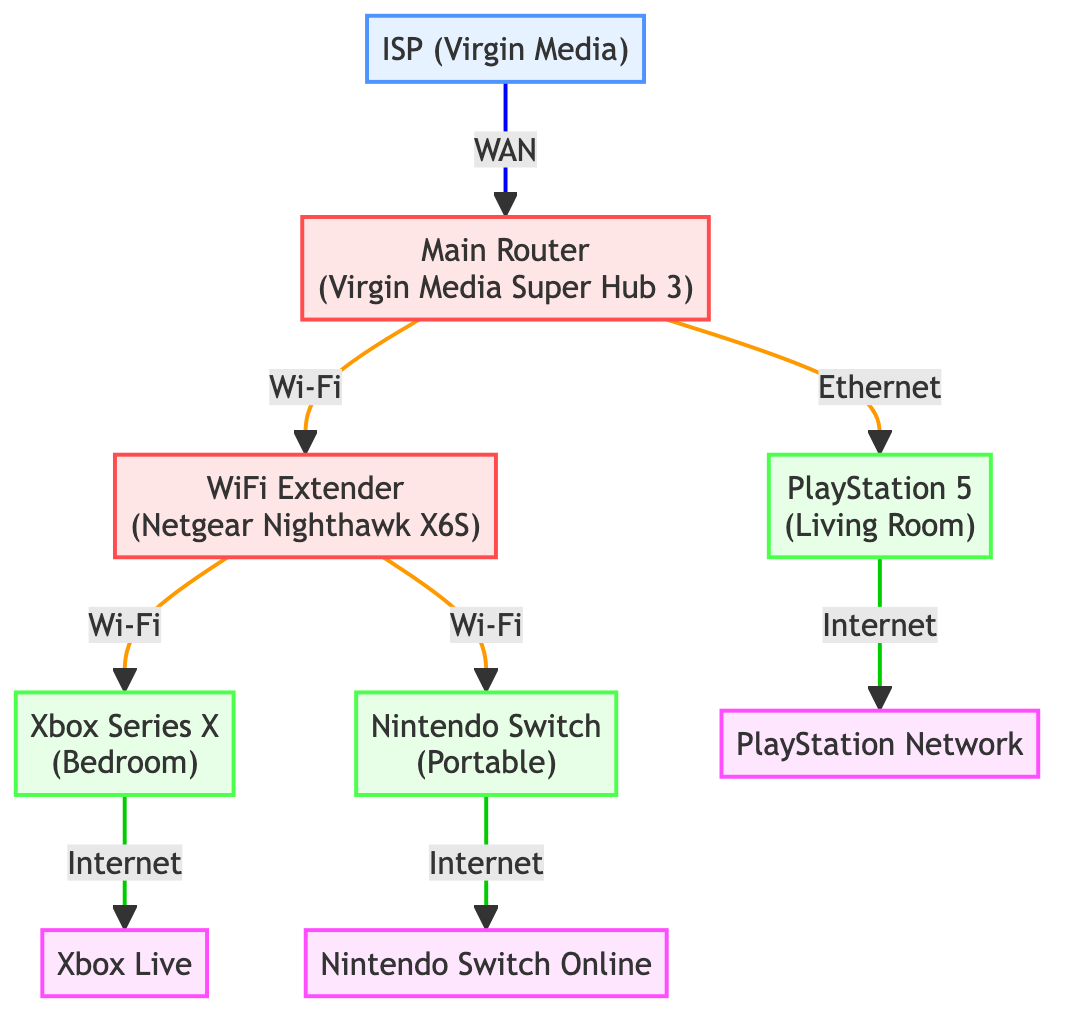What is the primary Internet Service Provider (ISP) represented in the diagram? The diagram specifically notes that the ISP is Virgin Media, which is indicated at the top of the network flow.
Answer: Virgin Media How many game consoles are connected in the network? By counting the nodes labeled as game consoles in the diagram, there are three: PlayStation 5, Xbox Series X, and Nintendo Switch.
Answer: 3 Which service is connected to the PlayStation 5? The diagram shows that the PlayStation 5 is connected to the PlayStation Network, specifically pointing to the online service node corresponding to PS5 online activities.
Answer: PlayStation Network What type of connection does the Main Router use to connect to the ISP? The diagram specifically labels the line from the ISP to the Main Router as a "WAN" connection type, indicating the nature of the connectivity in the network.
Answer: WAN Which console connects to the WiFi Extender? Based on the diagram, both the Xbox Series X and the Nintendo Switch are shown connected to the WiFi Extender via Wi-Fi connections, making them the only consoles linked to that router.
Answer: Xbox Series X and Nintendo Switch If the WiFi Extender fails, which console would still retain a direct wired connection to the network? The diagram shows that the PlayStation 5 is connected to the Main Router via Ethernet; therefore, it would maintain a direct connection, whereas the other consoles would lose connectivity through the extender.
Answer: PlayStation 5 How many Wi-Fi connections are depicted in the network? To find the number of Wi-Fi connections, we count the lines labeled as Wi-Fi in the diagram. There are three connections: one from the Main Router to the WiFi Extender, one from the WiFi Extender to the Xbox Series X, and one from the WiFi Extender to the Nintendo Switch.
Answer: 3 